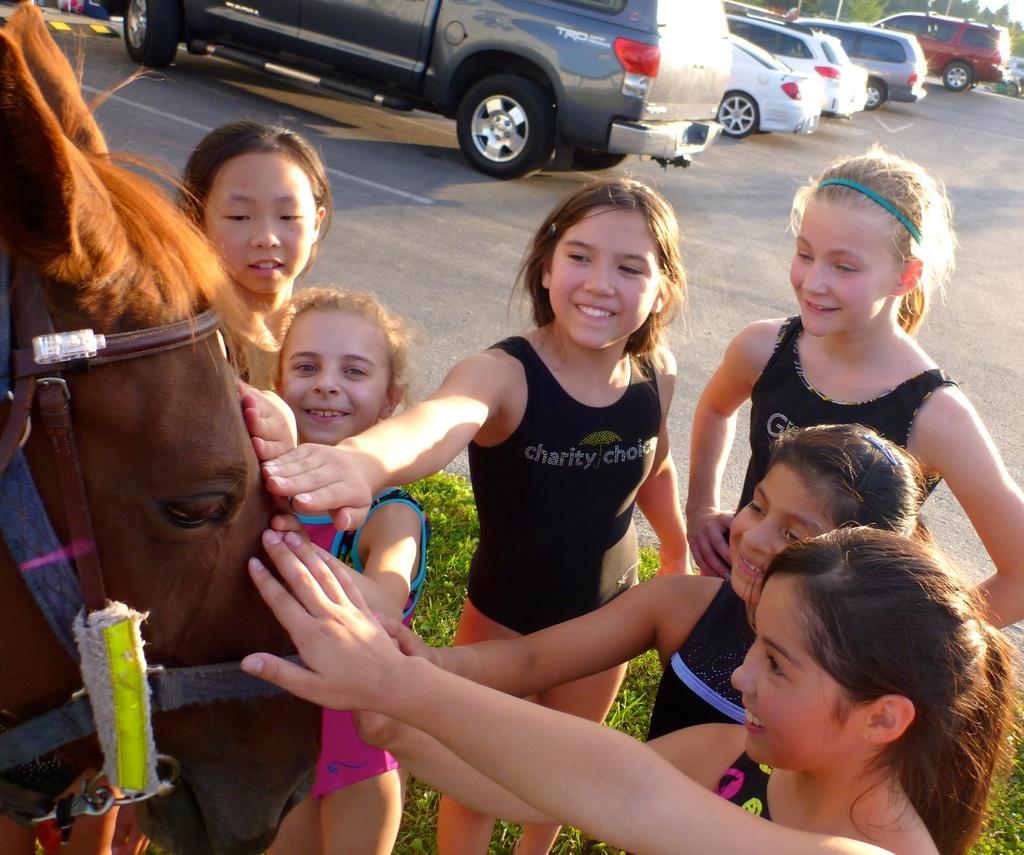In one or two sentences, can you explain what this image depicts? In this image I can see number of persons are standing and holding a horse which is brown in color. In the background I can see some grass, the ground, few vehicles, few trees and the sky. 